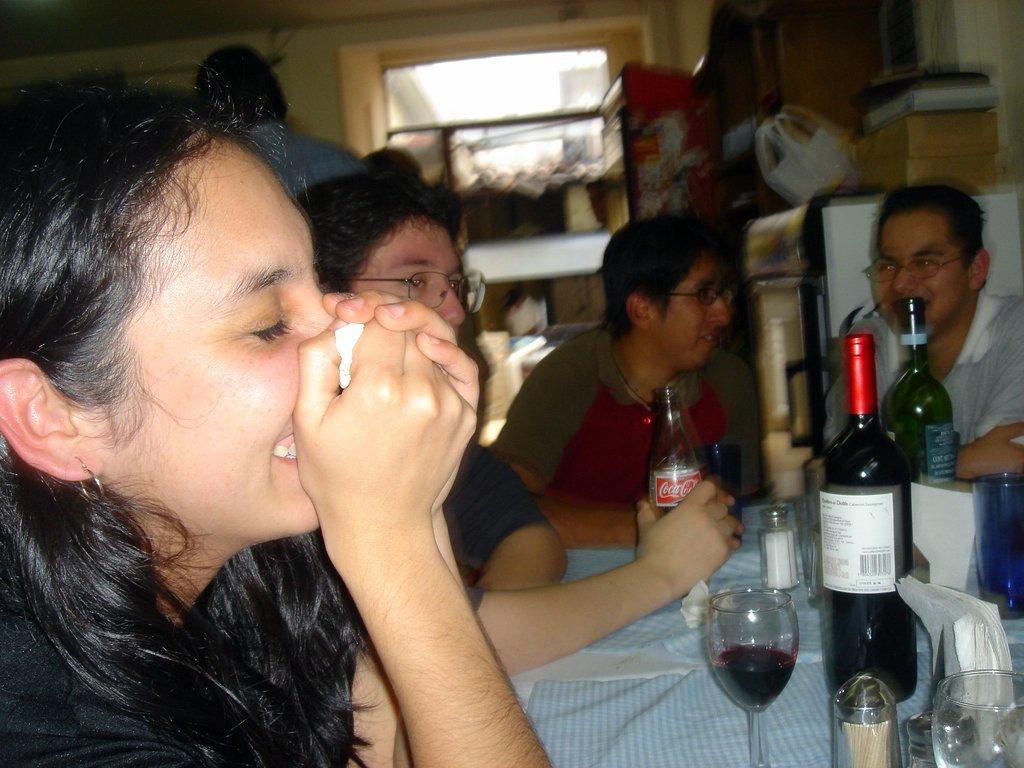Please provide a concise description of this image. In this picture there are four people sitting on the chair around the table on which there are some glasses and bottle and behind there is a fridge. 